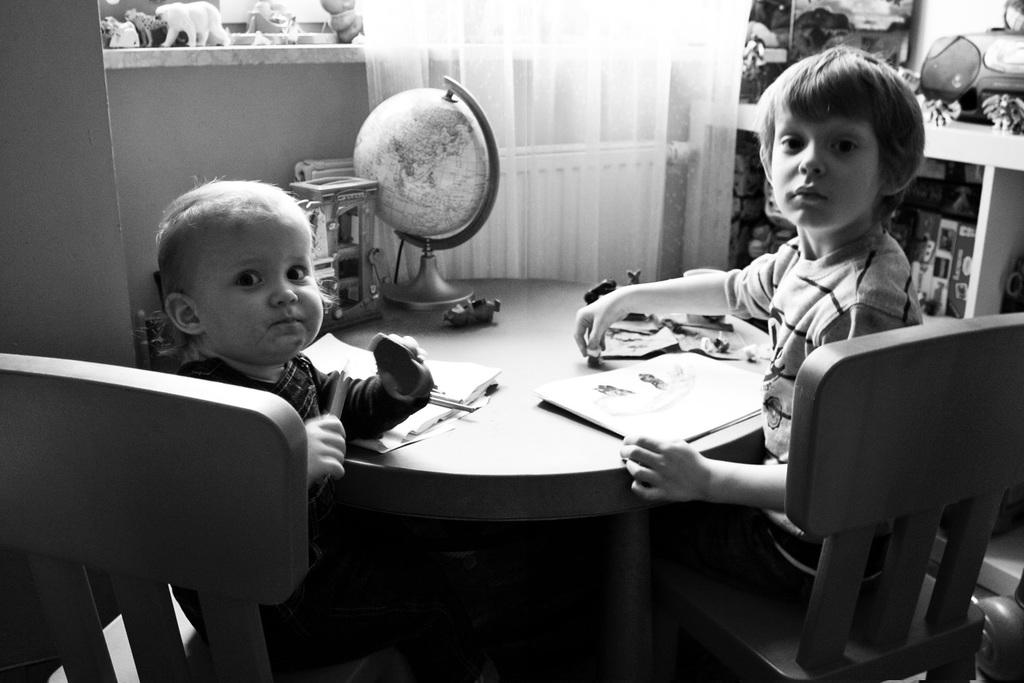How many people are sitting in the chair in the image? There are two persons sitting in a chair in the image. What is present on the table in the image? There is a globe, papers, and books on the table in the image. What can be seen in the background of the image? In the background, there is a curtain, a rack, and a cupboard. What type of bird is flying over the ship in the image? There is no bird or ship present in the image; it features two persons sitting in a chair, a table with a globe, papers, and books, and a background with a curtain, a rack, and a cupboard. 